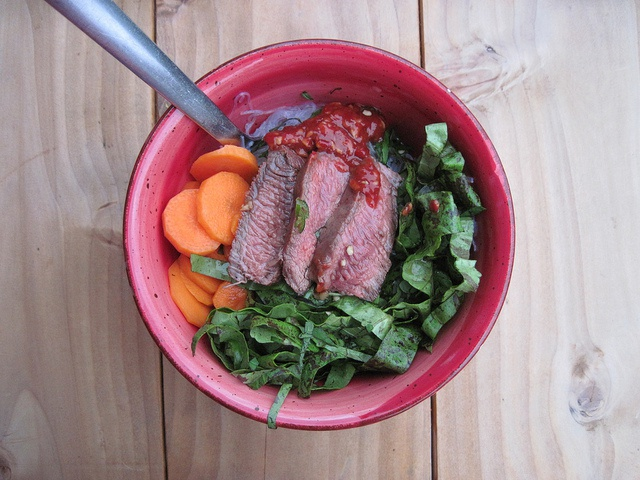Describe the objects in this image and their specific colors. I can see dining table in lightgray, darkgray, gray, and lightpink tones, bowl in gray, black, maroon, and brown tones, carrot in gray, salmon, red, and brown tones, spoon in gray and darkgray tones, and carrot in gray, red, brown, tan, and maroon tones in this image. 